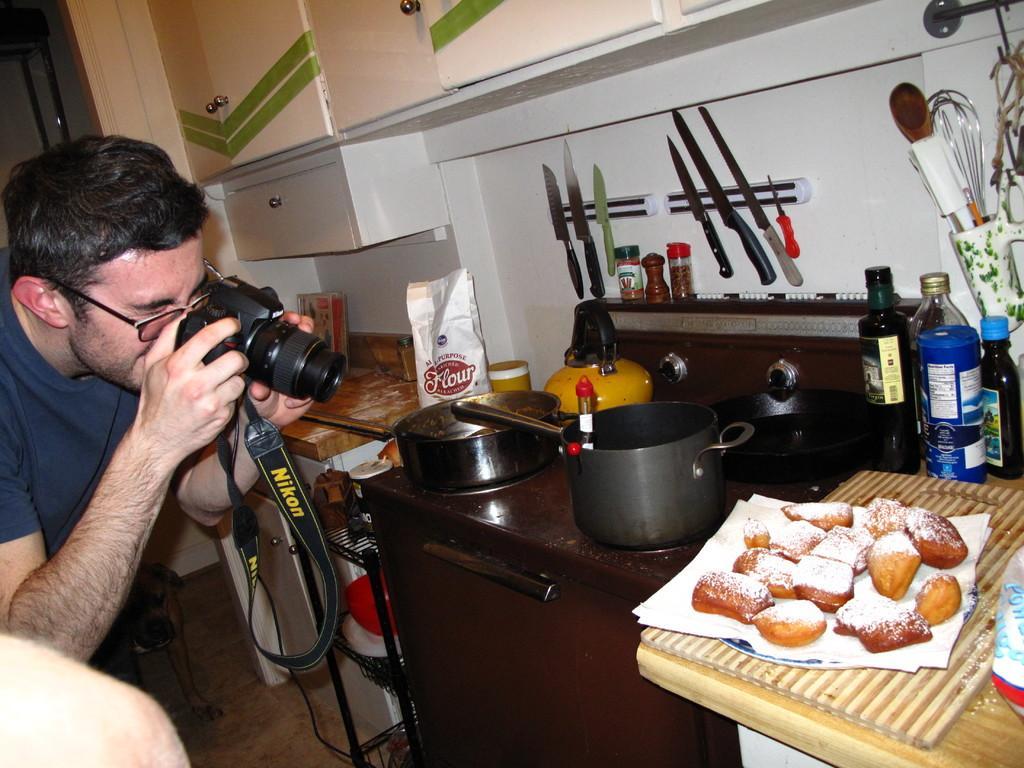Please provide a concise description of this image. In this image there is a man on the left side who is taking the picture of the food with the camera. On the right side there is a desk on which there are vessels,jars. It looks like a stove. There are few knives which are kept in the stand which is attached to the wall. On the right side there are glass bottles kept beside the food. At the top there are cupboards. 